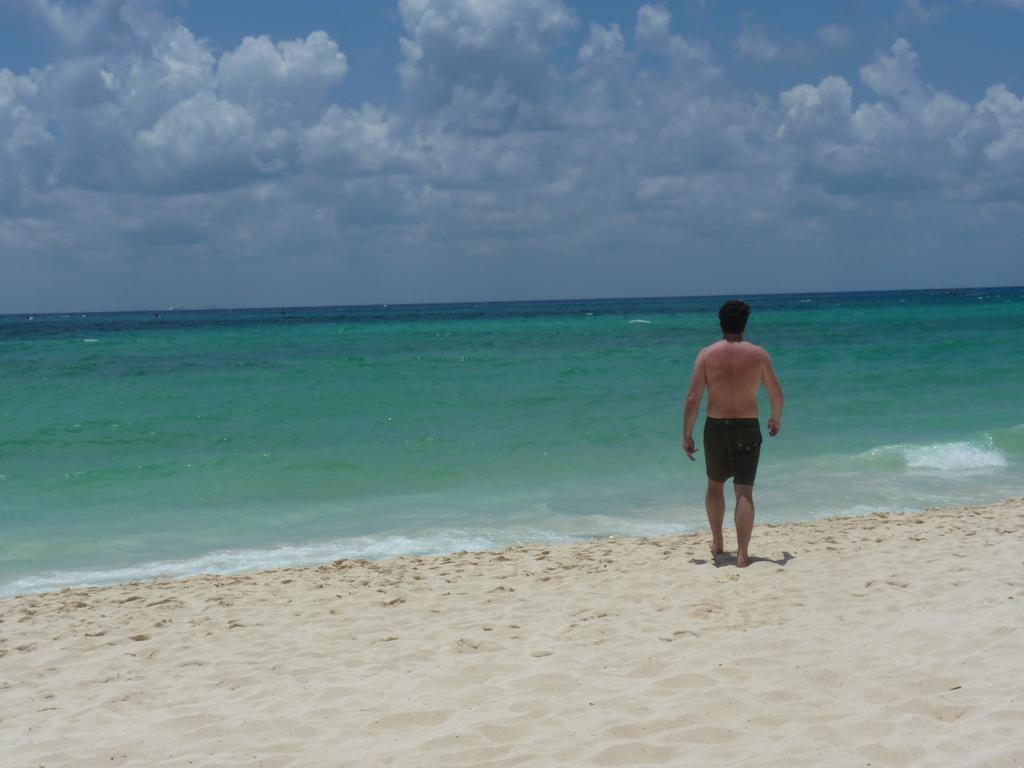What is the person standing on in the image? The person is standing on sand in the image. What can be seen in the background behind the person? There is water and the sky visible in the background. What is the condition of the sky in the image? The sky is visible in the background, and clouds are present. What type of grain is being harvested in the image? There is no grain or harvesting activity present in the image. Whose birthday is being celebrated in the image? There is no indication of a birthday celebration in the image. 